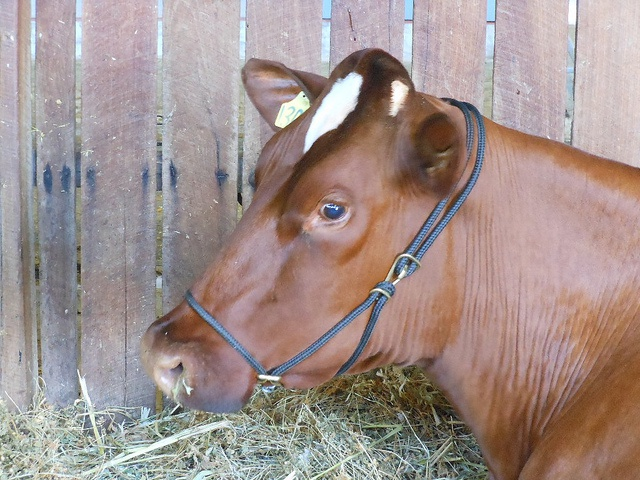Describe the objects in this image and their specific colors. I can see a cow in darkgray, gray, and salmon tones in this image. 